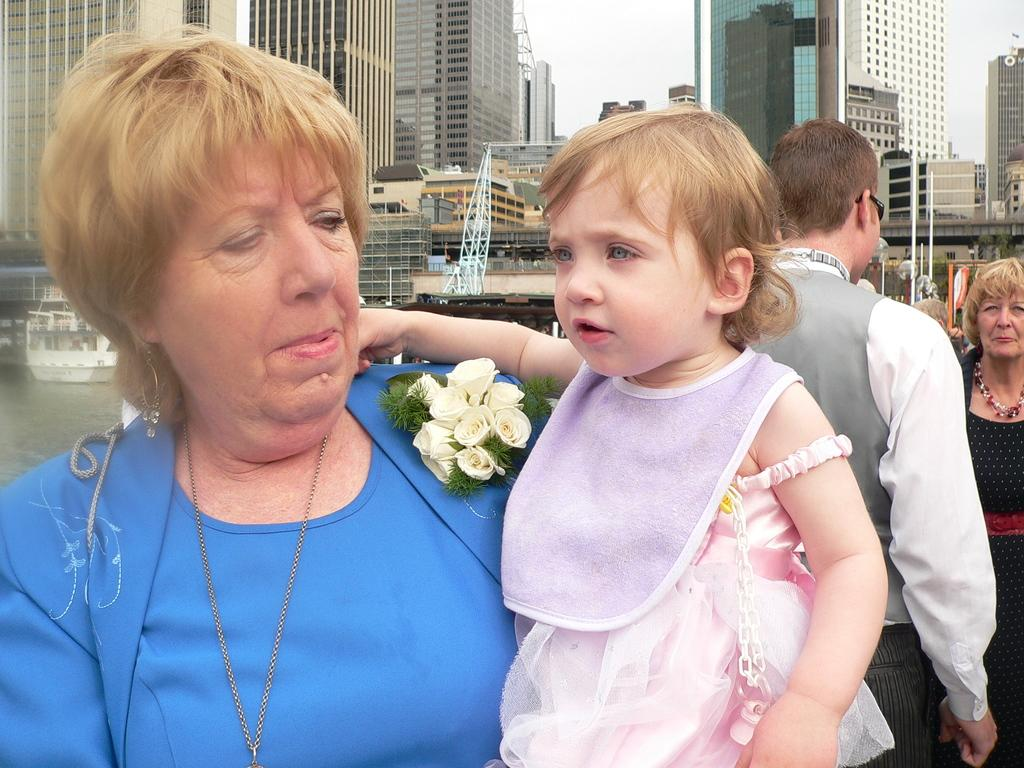Who or what can be seen in the image? There are people in the image. What type of vegetation is present in the image? There are flowers in the image. What is the water in the image used for? The water is likely used for boating, as there is a boat in the image. What type of structures are visible in the image? There are buildings in the image. What part of the natural environment is visible in the image? The sky is visible in the image. What advice does the pet give to the farmer in the image? There is no pet or farmer present in the image, so no such interaction can be observed. 